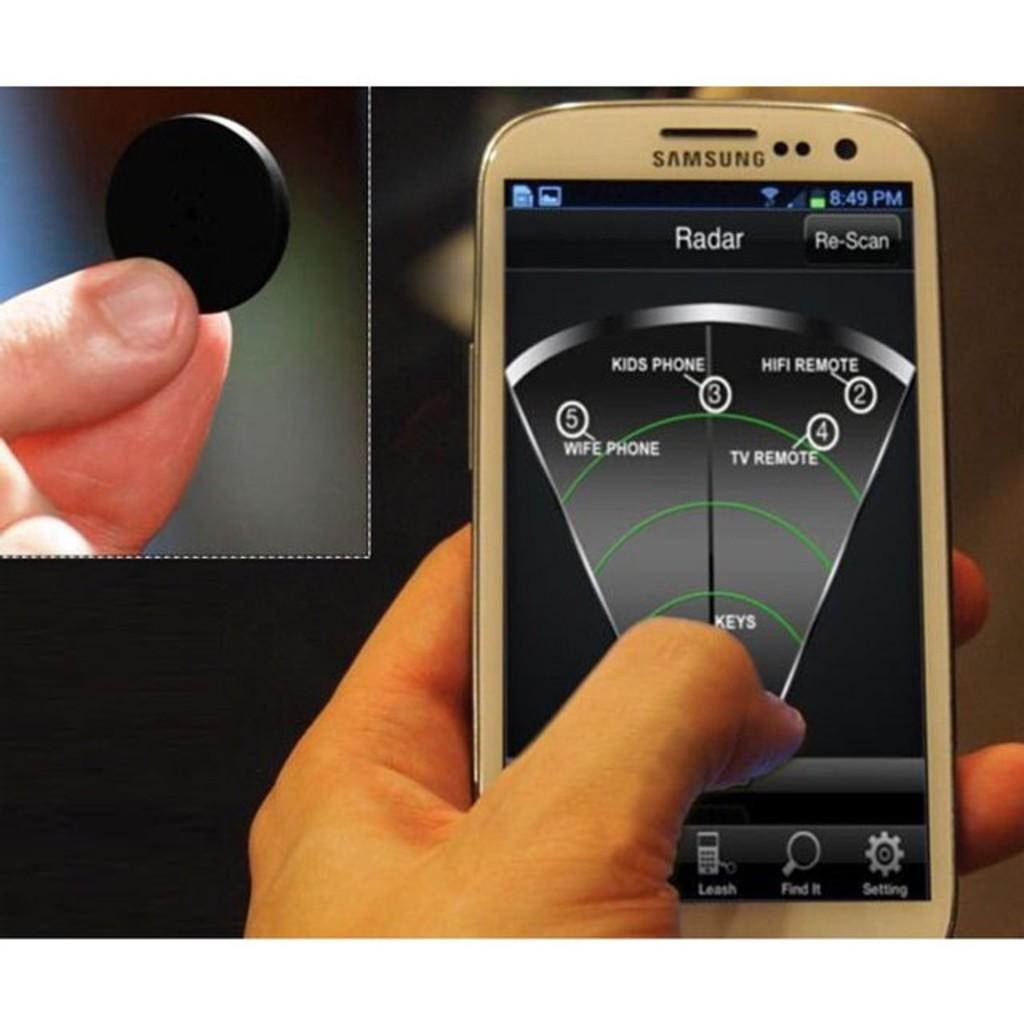<image>
Provide a brief description of the given image. A person is holding a cell phone that says Samsung and a black token. 